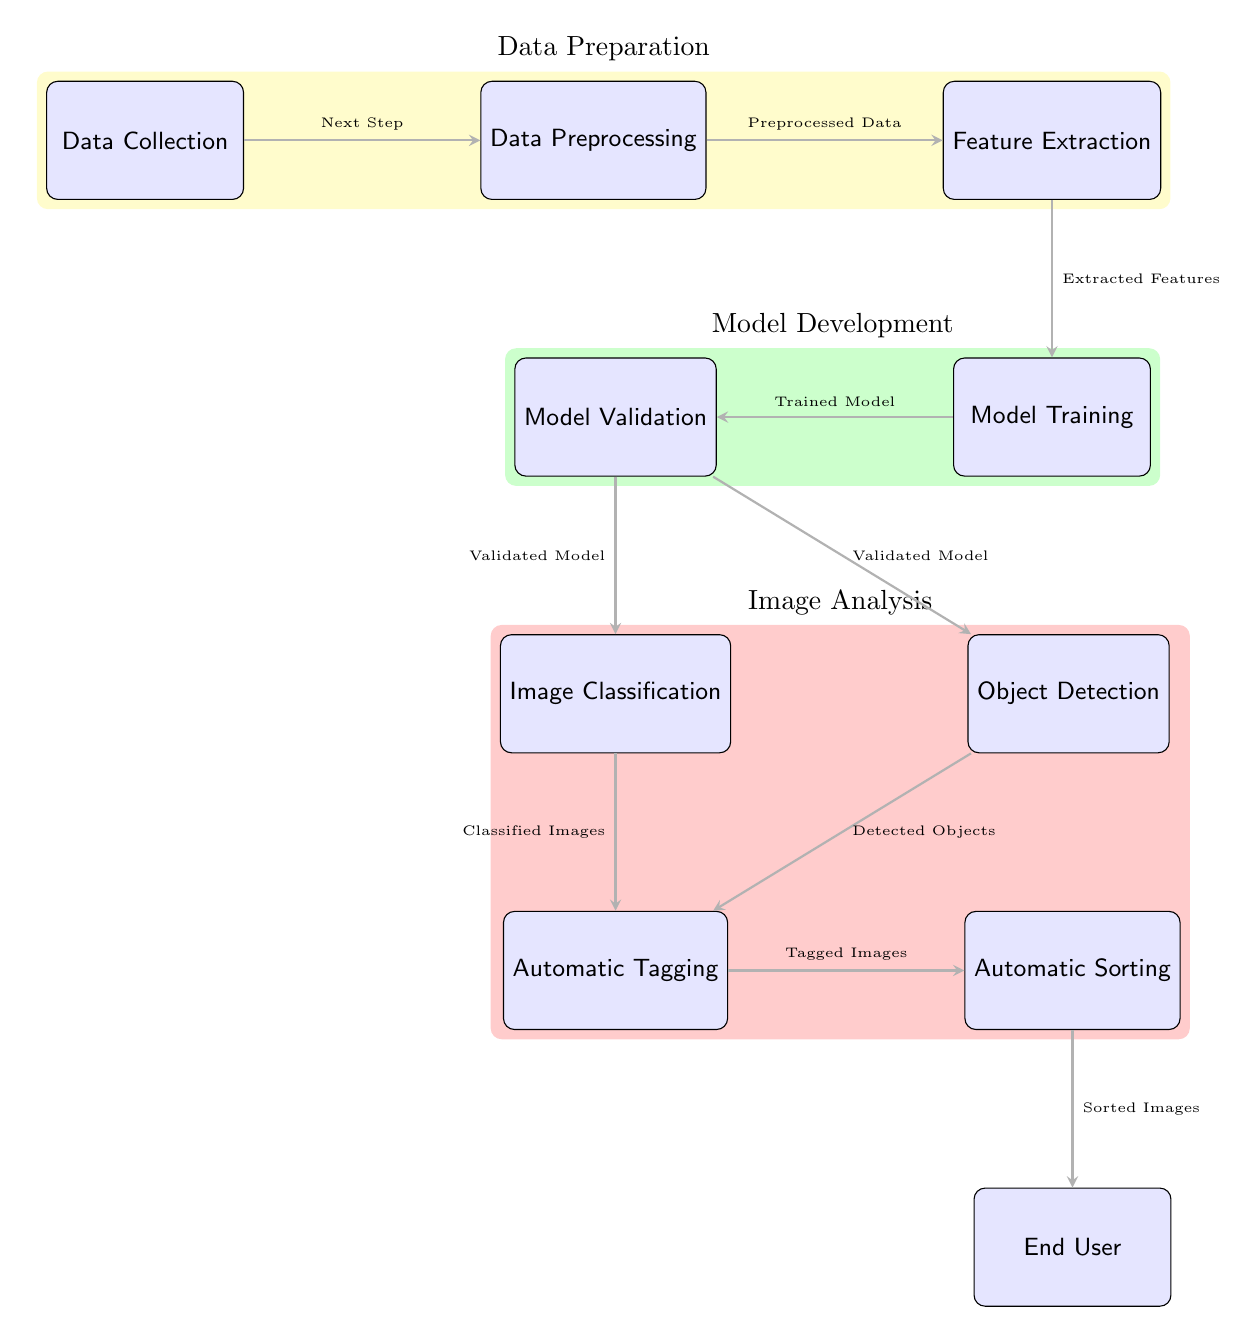What is the first step in the diagram? The diagram starts with the node labeled "Data Collection," which is the first stage in the process outlined.
Answer: Data Collection How many main sections are there in the diagram? There are three main sections highlighted in the diagram: Data Preparation, Model Development, and Image Analysis, each represented with colored backgrounds.
Answer: Three What is the output of the "Feature Extraction" step? The output of the "Feature Extraction" step is labeled as "Extracted Features," indicating what the step produces for downstream processing.
Answer: Extracted Features Which node comes before "Model Training"? "Feature Extraction" is the node located directly before "Model Training," providing the necessary data for training the model.
Answer: Feature Extraction How many edges are connected to the "Model Validation" node? The "Model Validation" node has two edges connecting it to the "Image Classification" and "Object Detection" nodes, indicating it influences both processes.
Answer: Two What is the final output that reaches the "End User"? The final output that reaches the "End User" is labeled "Sorted Images," which results from the "Automatic Sorting" step.
Answer: Sorted Images What are the two processes that rely on "Model Validation"? The two processes that rely on "Model Validation" are "Image Classification" and "Object Detection," indicating both depend on a validated model for their execution.
Answer: Image Classification, Object Detection What stage does the "Automatic Tagging" node come after? The "Automatic Tagging" node comes after both "Image Classification" and "Object Detection," meaning it uses results from both processes for tagging images.
Answer: Image Classification, Object Detection What type of analysis does the "Image Analysis" section represent? The "Image Analysis" section groups nodes that focus on analyzing images through classification and object detection, as well as tagging and sorting images afterward.
Answer: Analyzing images 